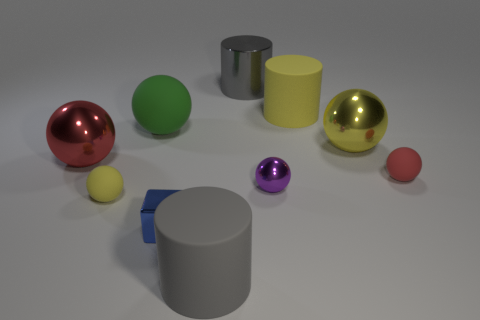What can you infer about the size of the objects relative to one another? Though the objects vary in color and texture, their sizes are consistent with one another, with pairs of objects appearing to be the same size. This suggests deliberate sizing to facilitate comparison or to create an artistic balance within the composition. 